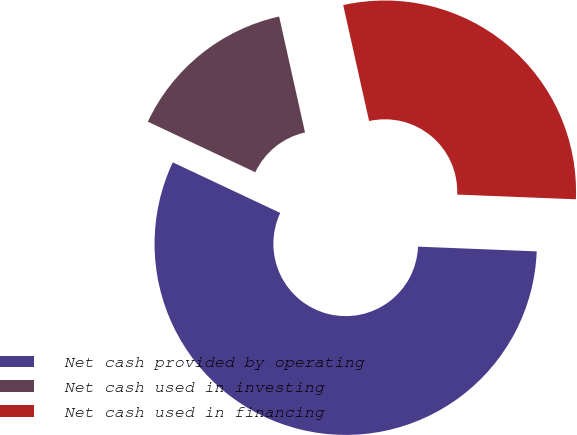Convert chart to OTSL. <chart><loc_0><loc_0><loc_500><loc_500><pie_chart><fcel>Net cash provided by operating<fcel>Net cash used in investing<fcel>Net cash used in financing<nl><fcel>56.36%<fcel>14.5%<fcel>29.13%<nl></chart> 